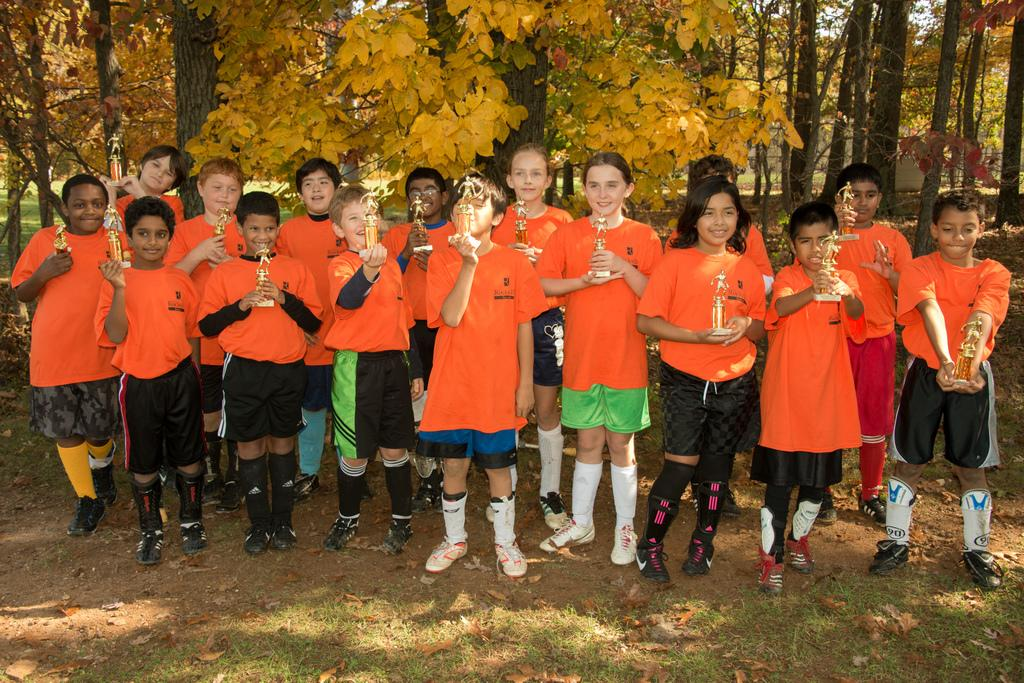What is happening in the image involving a group of people? There is a group of people in the image, and they are holding prizes in their hands. What can be seen in the background of the image? There are trees visible in the background of the image. What type of toothpaste is being used by the people in the image? There is no toothpaste present in the image; the people are holding prizes. What religious beliefs are being practiced by the people in the image? There is no information about religious beliefs in the image; it only shows a group of people holding prizes. 